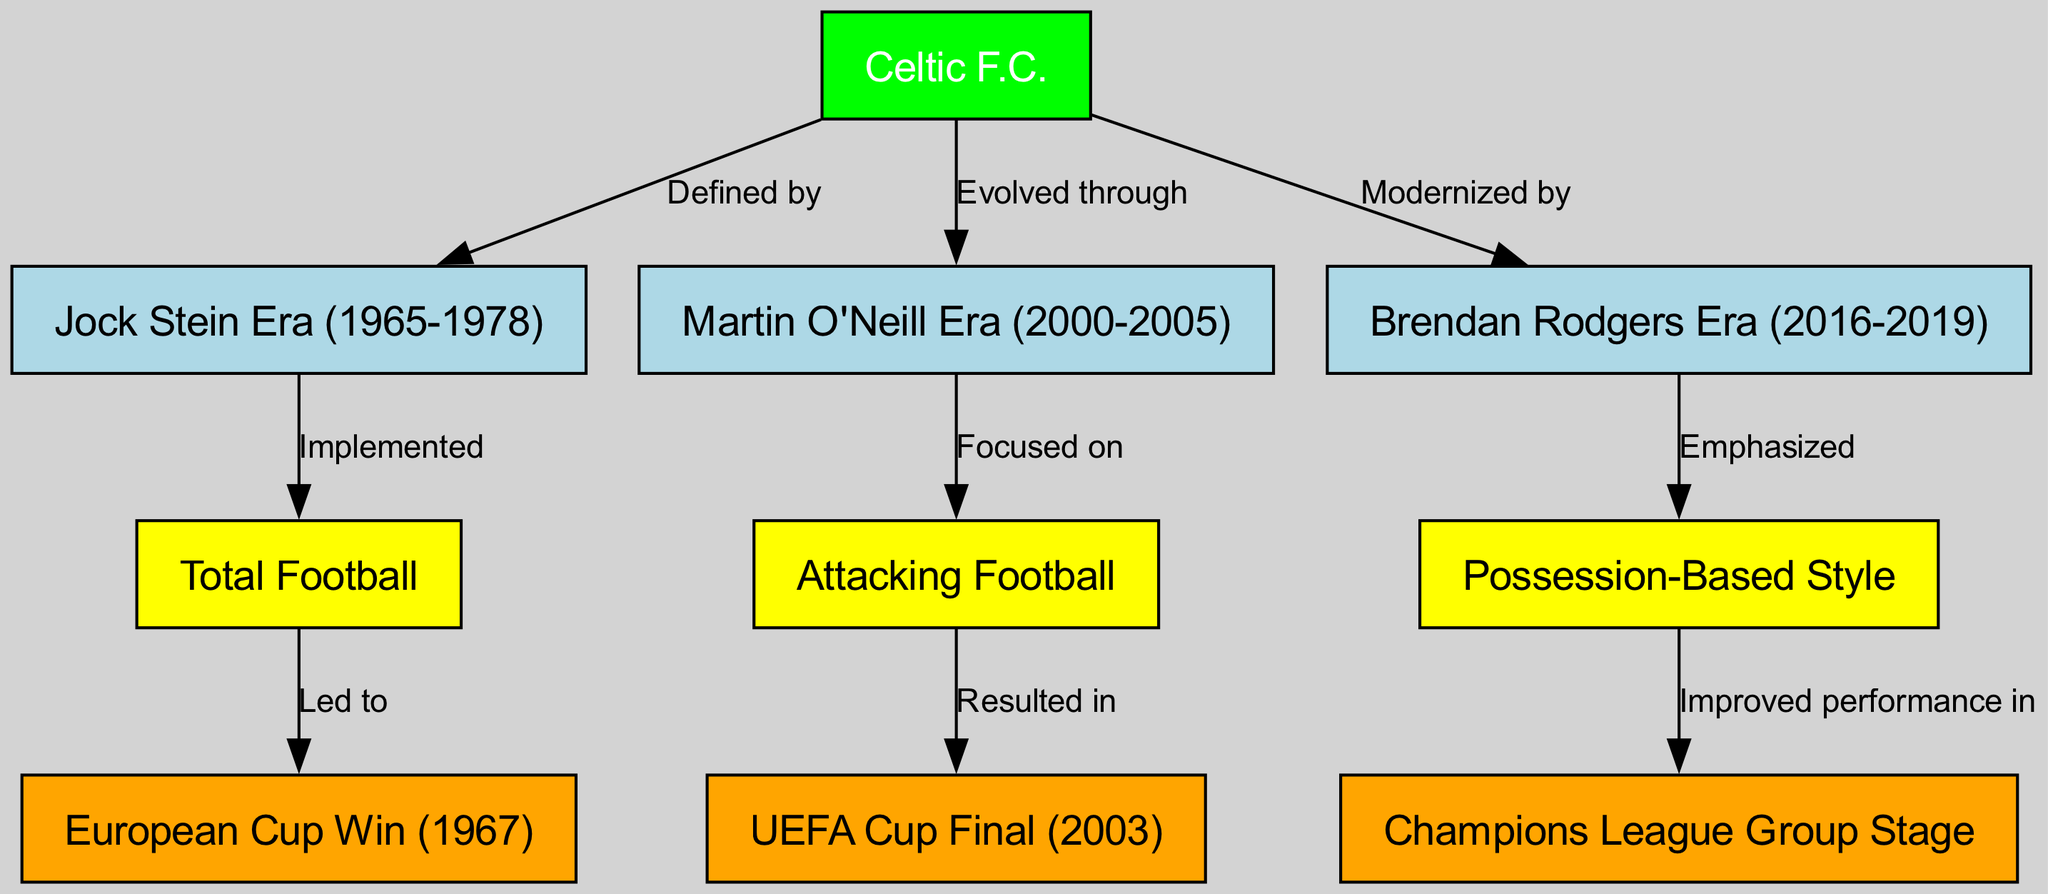What playing style is implemented in the Jock Stein Era? The diagram shows an edge from the Jock Stein Era to Total Football labeled "Implemented," indicating that Total Football is the specific playing style associated with this era.
Answer: Total Football Which European competition did Celtic F.C. win in 1967? Referring to the edge from Total Football to European Cup, labeled "Led to," we can see that Total Football led to Celtic's success in the European Cup in 1967.
Answer: European Cup How many eras of Celtic F.C. are depicted in the diagram? By counting the nodes labeled with "Era," we identify three specific nodes: Jock Stein Era, Martin O'Neill Era, and Brendan Rodgers Era—this totals three eras represented in the concept map.
Answer: 3 What is the focus of Martin O'Neill's era? The edge leading from Martin O'Neill Era to Attacking Football, labeled "Focused on," directly indicates that the focus during Martin O'Neill's era was on Attacking Football.
Answer: Attacking Football Which style of play did Brendan Rodgers emphasize? The diagram shows an edge from Brendan Rodgers Era to Possession-Based, labeled "Emphasized," revealing that Brendan Rodgers emphasized a Possession-Based style of play.
Answer: Possession-Based What was the result of the focus on Attacking Football during Martin O'Neill's era? Referring to the relationship between Attacking Football and UEFA Cup Final, we see that the focus on Attacking Football resulted in reaching the UEFA Cup Final in 2003.
Answer: UEFA Cup Final How did the Jock Stein Era influence Celtic's success? Analyzing how Total Football is connected to the European Cup in 1967, we find that the implementation of Total Football during the Jock Stein Era had a direct influence on Celtic's historic success in the European Cup.
Answer: European Cup Which playing style improved performance in the Champions League? The diagram indicates a connection from Possession-Based to Champions League, labeled "Improved performance in," which shows that emphasis on Possession-Based style contributed to better performance in this competition.
Answer: Possession-Based 